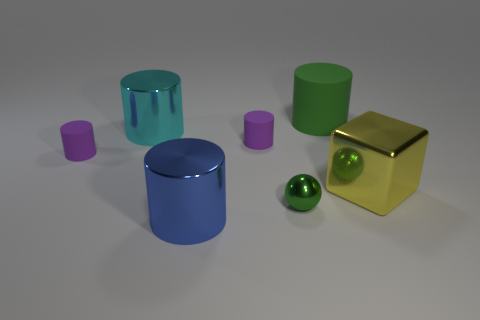Add 2 small matte cylinders. How many objects exist? 9 Subtract all red cylinders. Subtract all purple balls. How many cylinders are left? 5 Subtract all balls. How many objects are left? 6 Subtract 0 red cylinders. How many objects are left? 7 Subtract all big green metallic spheres. Subtract all yellow blocks. How many objects are left? 6 Add 3 large blue cylinders. How many large blue cylinders are left? 4 Add 5 cyan shiny objects. How many cyan shiny objects exist? 6 